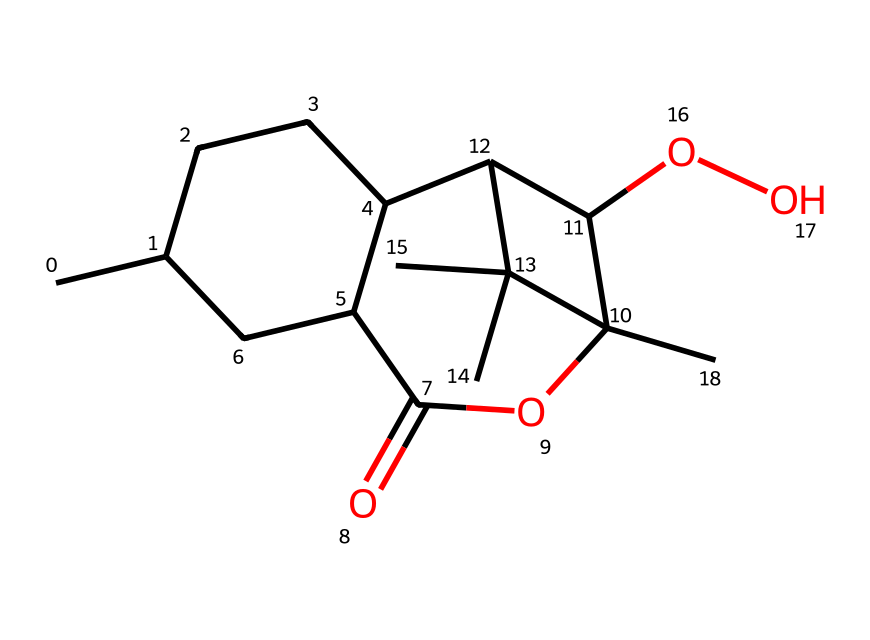How many carbon atoms are present in this chemical? By analyzing the SMILES representation, we can count the carbon atoms represented by 'C' in the structure. This chemical structure contains 15 carbon atoms.
Answer: 15 What functional groups are present in this molecule? Looking closely at the SMILES, the presence of 'O' indicates the presence of an ester due to the 'C(=O)OC' segment. Additionally, ‘OO’ signifies a hydroxyl (alcohol) group. Thus, the functional groups in this chemical are an ester and alcohol.
Answer: ester and alcohol What is the molecular formula of this compound? From the SMILES, we count the atoms: 15 carbons (C), 28 hydrogens (H), and 5 oxygens (O), leading to a molecular formula. Therefore, the molecular formula can be derived as C15H28O5.
Answer: C15H28O5 Does this chemical structure contain any rings? The SMILES representation contains numerals (1, 2, 3) that indicate the presence of cyclic structures or rings. We can identify at least three cyclic structures based on the linking of these numbers.
Answer: Yes What properties might this chemical possess due to its specific structure? This molecule contains multiple functional groups and a complex cyclic structure, which often correlate to properties like higher potency against malaria. The presence of rings can also impact solubility and bioavailability.
Answer: Antimalarial properties Is this chemical likely to be a low or high molecular weight drug? The molecular weight can be calculated from the molecular formula. Given a total of 15 carbons, 28 hydrogens, and 5 oxygens, the molecular weight is approximately 284.4 g/mol, indicating it is a low molecular weight drug, which is often favorable in drug design.
Answer: Low molecular weight 